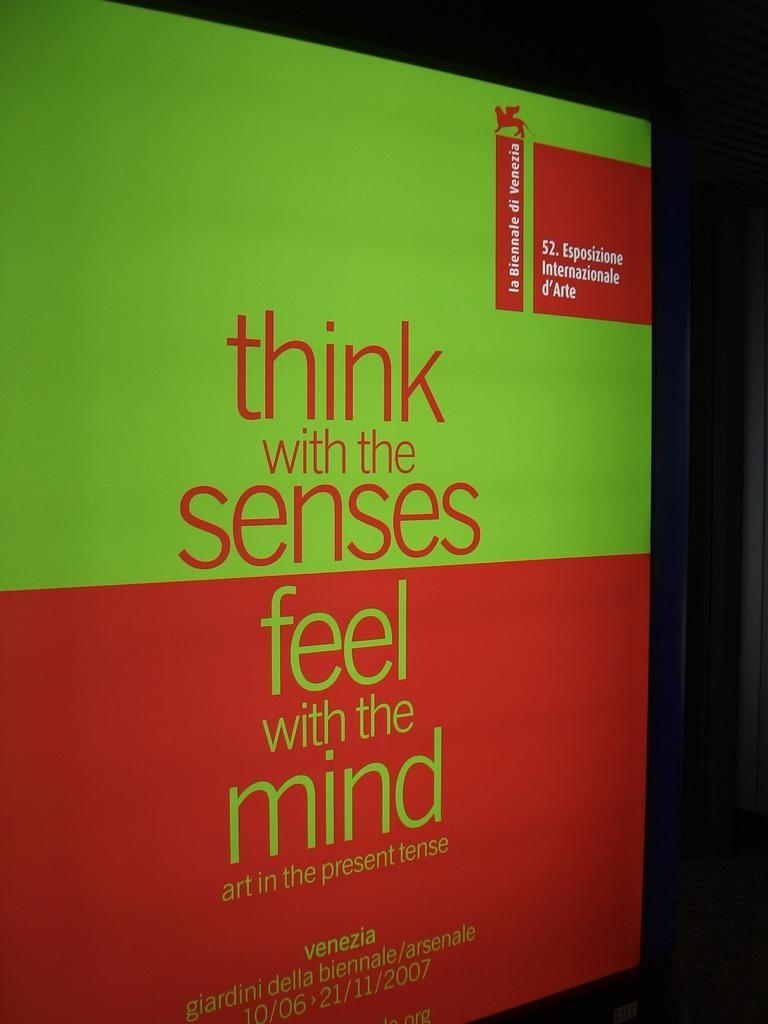<image>
Relay a brief, clear account of the picture shown. A sign that says think with the senses feel with the mind 